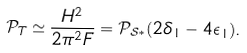Convert formula to latex. <formula><loc_0><loc_0><loc_500><loc_500>\mathcal { P } _ { T } \simeq \frac { H ^ { 2 } } { 2 \pi ^ { 2 } F } = \mathcal { P } _ { \mathcal { S } \ast } ( 2 \delta _ { 1 } - 4 \epsilon _ { 1 } ) .</formula> 